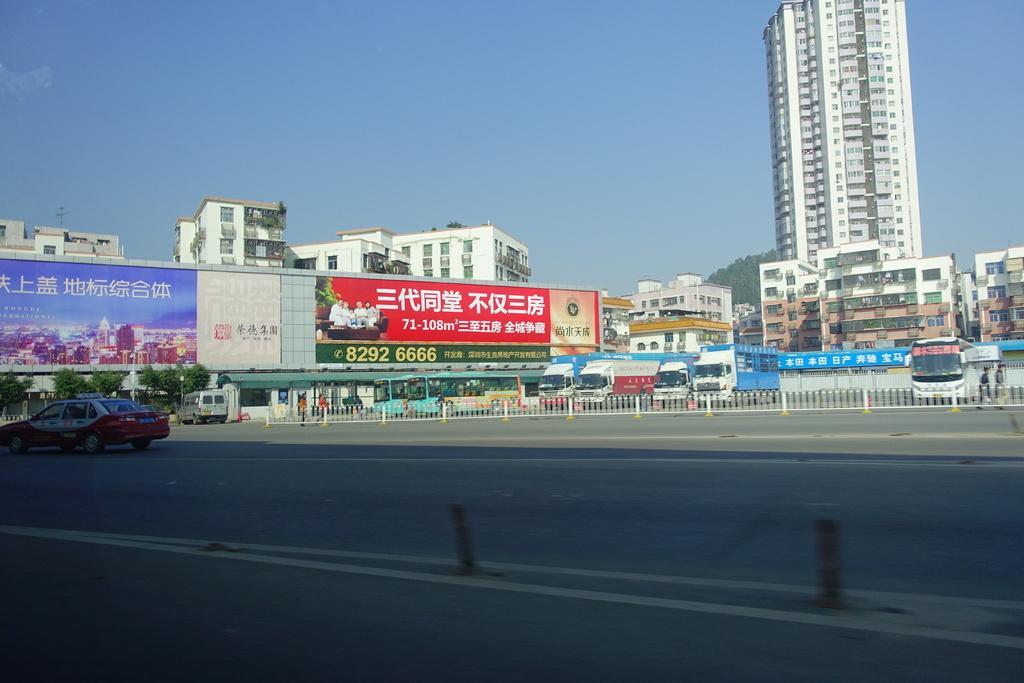In one or two sentences, can you explain what this image depicts? In this image I can see few vehicles on roads in the front. In the background I can see few boards, number of buildings, few trees, the sky and on these boards I can see something is written. 